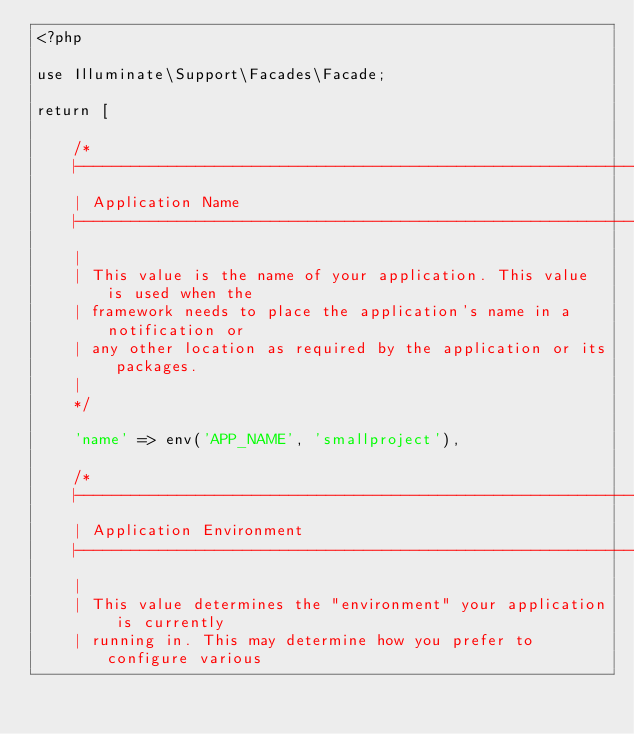<code> <loc_0><loc_0><loc_500><loc_500><_PHP_><?php

use Illuminate\Support\Facades\Facade;

return [

    /*
    |--------------------------------------------------------------------------
    | Application Name
    |--------------------------------------------------------------------------
    |
    | This value is the name of your application. This value is used when the
    | framework needs to place the application's name in a notification or
    | any other location as required by the application or its packages.
    |
    */

    'name' => env('APP_NAME', 'smallproject'),

    /*
    |--------------------------------------------------------------------------
    | Application Environment
    |--------------------------------------------------------------------------
    |
    | This value determines the "environment" your application is currently
    | running in. This may determine how you prefer to configure various</code> 